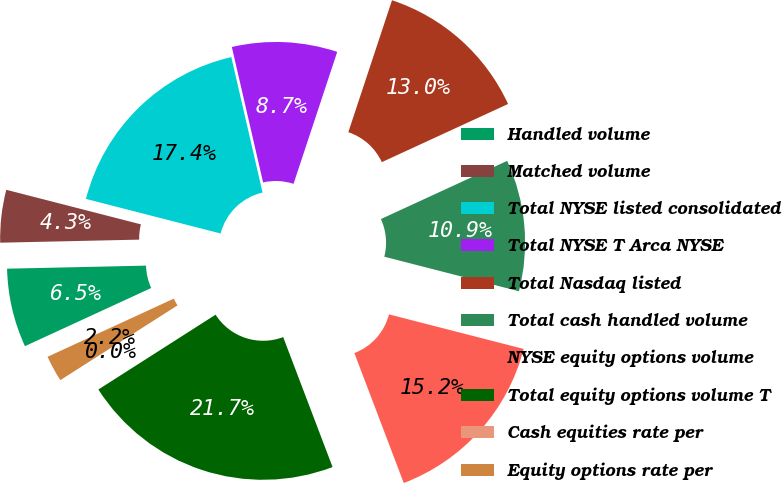<chart> <loc_0><loc_0><loc_500><loc_500><pie_chart><fcel>Handled volume<fcel>Matched volume<fcel>Total NYSE listed consolidated<fcel>Total NYSE T Arca NYSE<fcel>Total Nasdaq listed<fcel>Total cash handled volume<fcel>NYSE equity options volume<fcel>Total equity options volume T<fcel>Cash equities rate per<fcel>Equity options rate per<nl><fcel>6.52%<fcel>4.35%<fcel>17.39%<fcel>8.7%<fcel>13.04%<fcel>10.87%<fcel>15.22%<fcel>21.74%<fcel>0.0%<fcel>2.17%<nl></chart> 